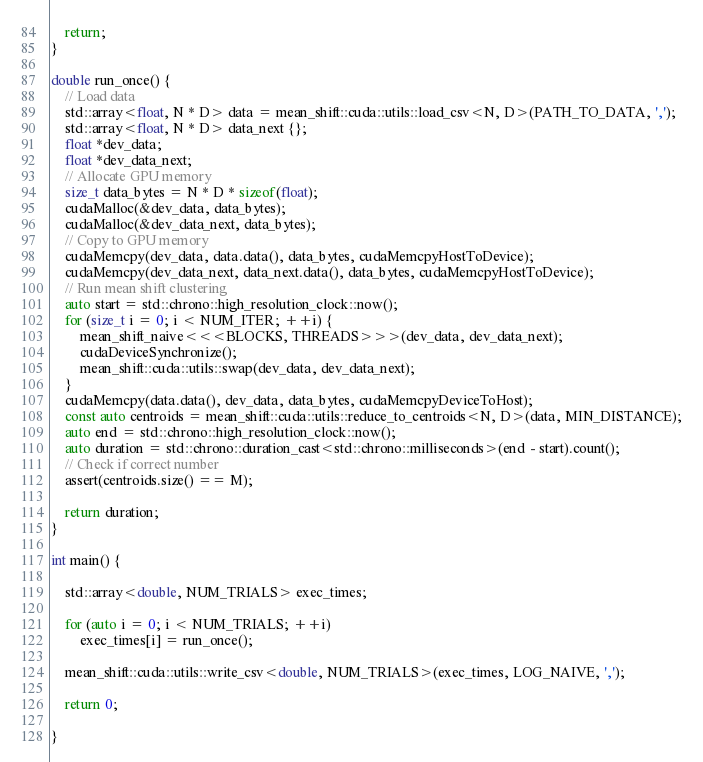<code> <loc_0><loc_0><loc_500><loc_500><_Cuda_>    return;
}

double run_once() {
    // Load data
    std::array<float, N * D> data = mean_shift::cuda::utils::load_csv<N, D>(PATH_TO_DATA, ',');
    std::array<float, N * D> data_next {};
    float *dev_data;
    float *dev_data_next;
    // Allocate GPU memory
    size_t data_bytes = N * D * sizeof(float);
    cudaMalloc(&dev_data, data_bytes);
    cudaMalloc(&dev_data_next, data_bytes);
    // Copy to GPU memory
    cudaMemcpy(dev_data, data.data(), data_bytes, cudaMemcpyHostToDevice);
    cudaMemcpy(dev_data_next, data_next.data(), data_bytes, cudaMemcpyHostToDevice);
    // Run mean shift clustering
    auto start = std::chrono::high_resolution_clock::now();
    for (size_t i = 0; i < NUM_ITER; ++i) {
        mean_shift_naive<<<BLOCKS, THREADS>>>(dev_data, dev_data_next);
        cudaDeviceSynchronize();
        mean_shift::cuda::utils::swap(dev_data, dev_data_next);
    }
    cudaMemcpy(data.data(), dev_data, data_bytes, cudaMemcpyDeviceToHost);
    const auto centroids = mean_shift::cuda::utils::reduce_to_centroids<N, D>(data, MIN_DISTANCE);
    auto end = std::chrono::high_resolution_clock::now();
    auto duration = std::chrono::duration_cast<std::chrono::milliseconds>(end - start).count();
    // Check if correct number
    assert(centroids.size() == M);
    
    return duration;
}

int main() {

    std::array<double, NUM_TRIALS> exec_times;

    for (auto i = 0; i < NUM_TRIALS; ++i)
        exec_times[i] = run_once();

    mean_shift::cuda::utils::write_csv<double, NUM_TRIALS>(exec_times, LOG_NAIVE, ',');

    return 0;

}</code> 